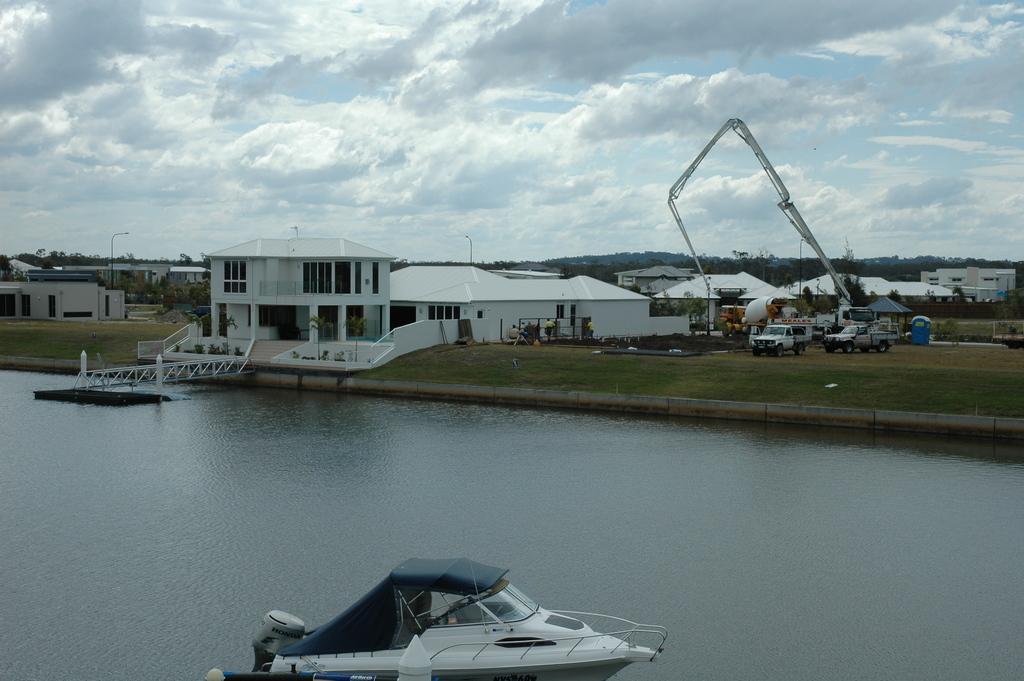In one or two sentences, can you explain what this image depicts? In this picture we can observe a white color boat on the water. We can observe houses which were in white color. There is a mobile crane on the right side and two vehicles on the ground. In the background there are trees and a sky with clouds. 